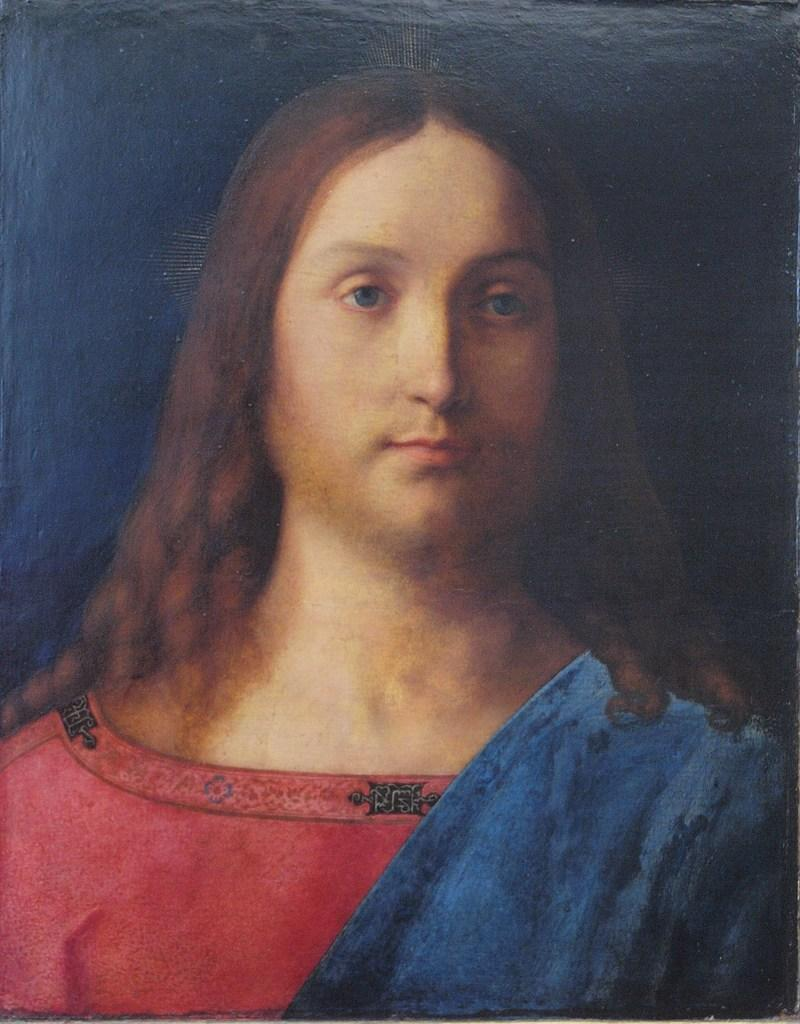What is the main subject of the image? There is a painting in the image. What does the painting depict? The painting depicts a person. What color is the background of the painting? There is a blue background in the image. How many branches can be seen growing from the person's head in the image? There are no branches visible in the image; it features a painting of a person with a blue background. What type of print is visible on the person's clothing in the image? There is no print visible on the person's clothing in the image, as it is a painting and not a photograph. 